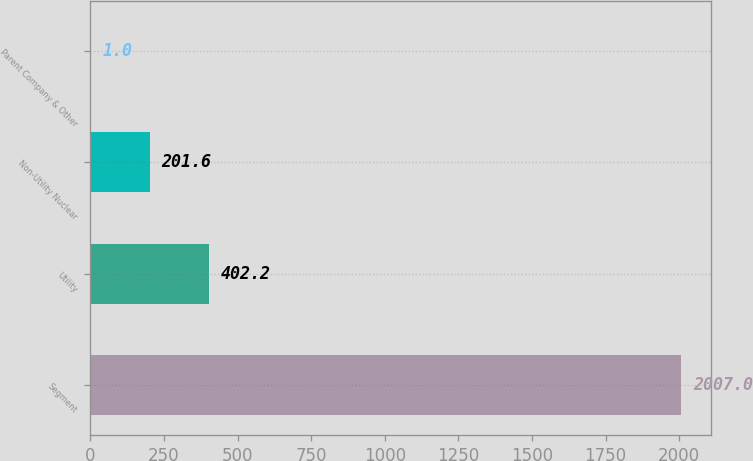Convert chart. <chart><loc_0><loc_0><loc_500><loc_500><bar_chart><fcel>Segment<fcel>Utility<fcel>Non-Utility Nuclear<fcel>Parent Company & Other<nl><fcel>2007<fcel>402.2<fcel>201.6<fcel>1<nl></chart> 